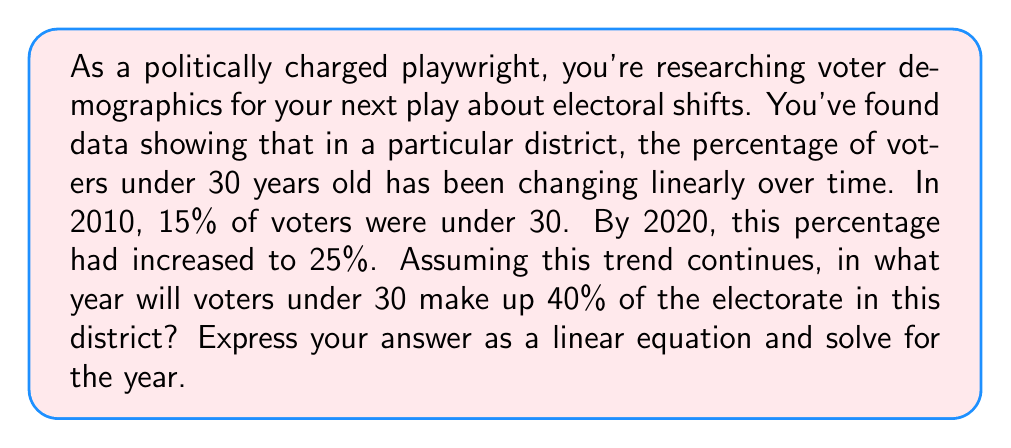Could you help me with this problem? Let's approach this step-by-step using a linear equation:

1) Let $y$ represent the percentage of voters under 30, and $x$ represent the number of years since 2010.

2) We can write the linear equation in the form $y = mx + b$, where $m$ is the slope (rate of change) and $b$ is the y-intercept (initial value).

3) We know two points:
   (0, 15) for 2010
   (10, 25) for 2020

4) Calculate the slope:
   $m = \frac{y_2 - y_1}{x_2 - x_1} = \frac{25 - 15}{10 - 0} = \frac{10}{10} = 1$

5) The y-intercept is 15 (the percentage in 2010).

6) Our linear equation is:
   $y = x + 15$

7) We want to know when $y = 40$, so we substitute:
   $40 = x + 15$

8) Solve for $x$:
   $x = 40 - 15 = 25$

9) Since $x$ represents years since 2010, we add 25 to 2010 to get the year.
Answer: The year when voters under 30 will make up 40% of the electorate is 2035. This is found by solving the equation $40 = x + 15$ for $x$, which gives $x = 25$, representing 25 years after 2010. 